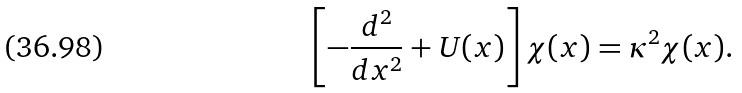Convert formula to latex. <formula><loc_0><loc_0><loc_500><loc_500>\left [ - \frac { d ^ { 2 } } { d x ^ { 2 } } + U ( x ) \right ] \chi ( x ) = \kappa ^ { 2 } \chi ( x ) .</formula> 